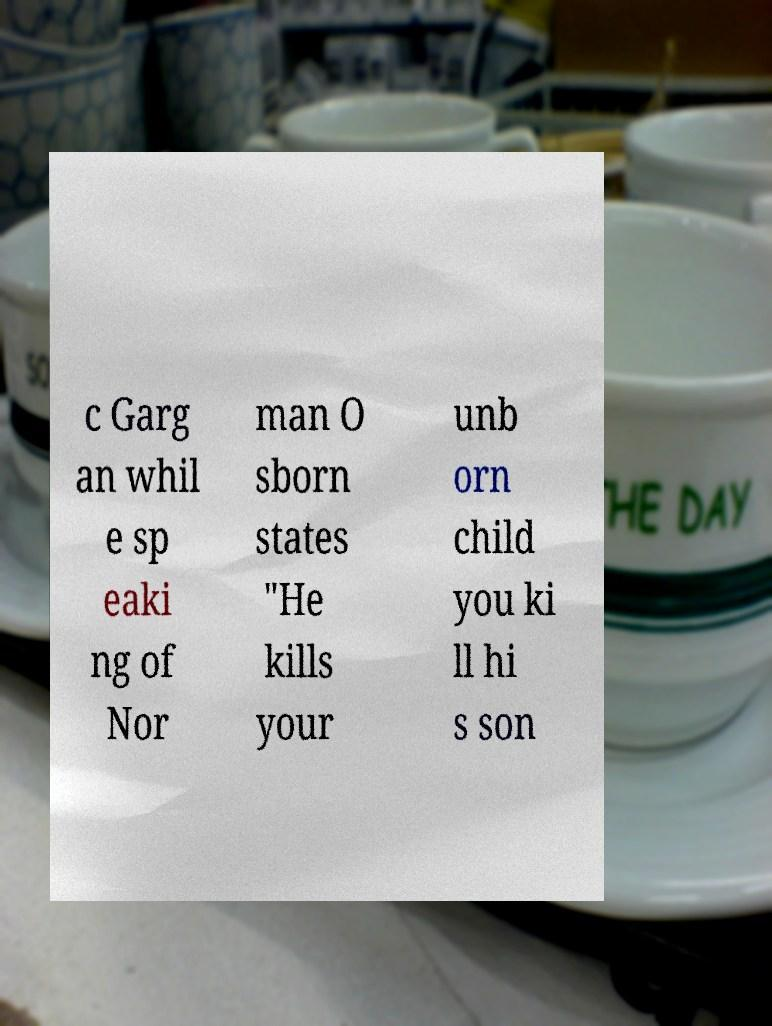Please identify and transcribe the text found in this image. c Garg an whil e sp eaki ng of Nor man O sborn states "He kills your unb orn child you ki ll hi s son 